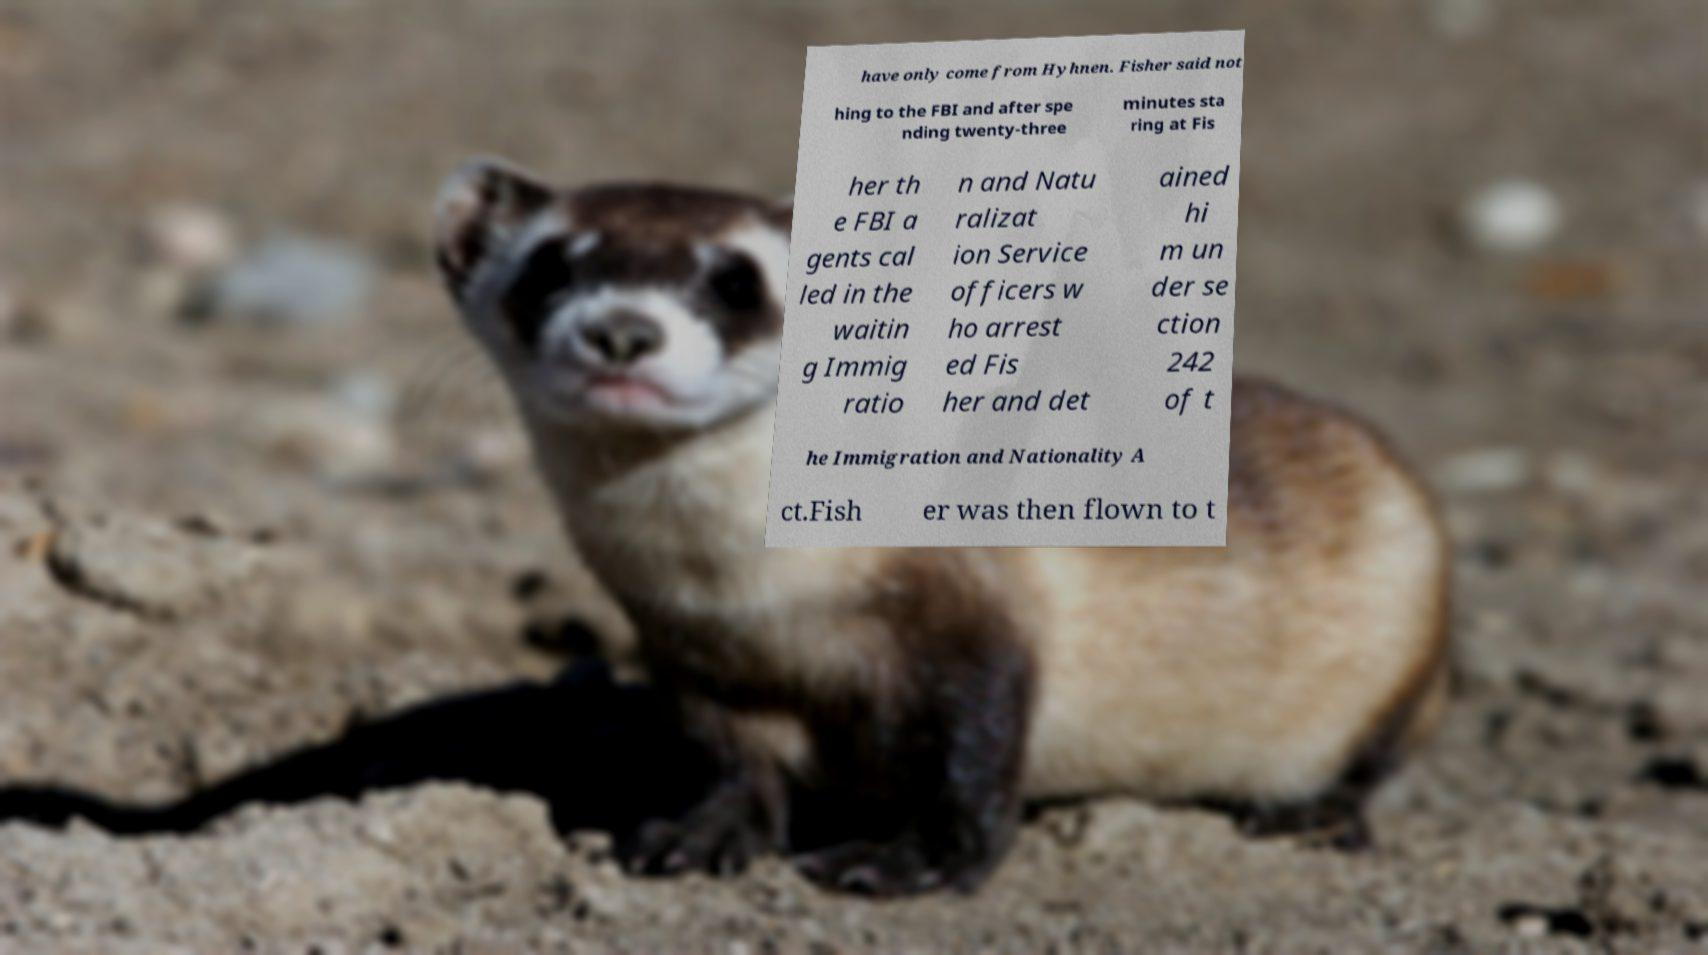Please identify and transcribe the text found in this image. have only come from Hyhnen. Fisher said not hing to the FBI and after spe nding twenty-three minutes sta ring at Fis her th e FBI a gents cal led in the waitin g Immig ratio n and Natu ralizat ion Service officers w ho arrest ed Fis her and det ained hi m un der se ction 242 of t he Immigration and Nationality A ct.Fish er was then flown to t 